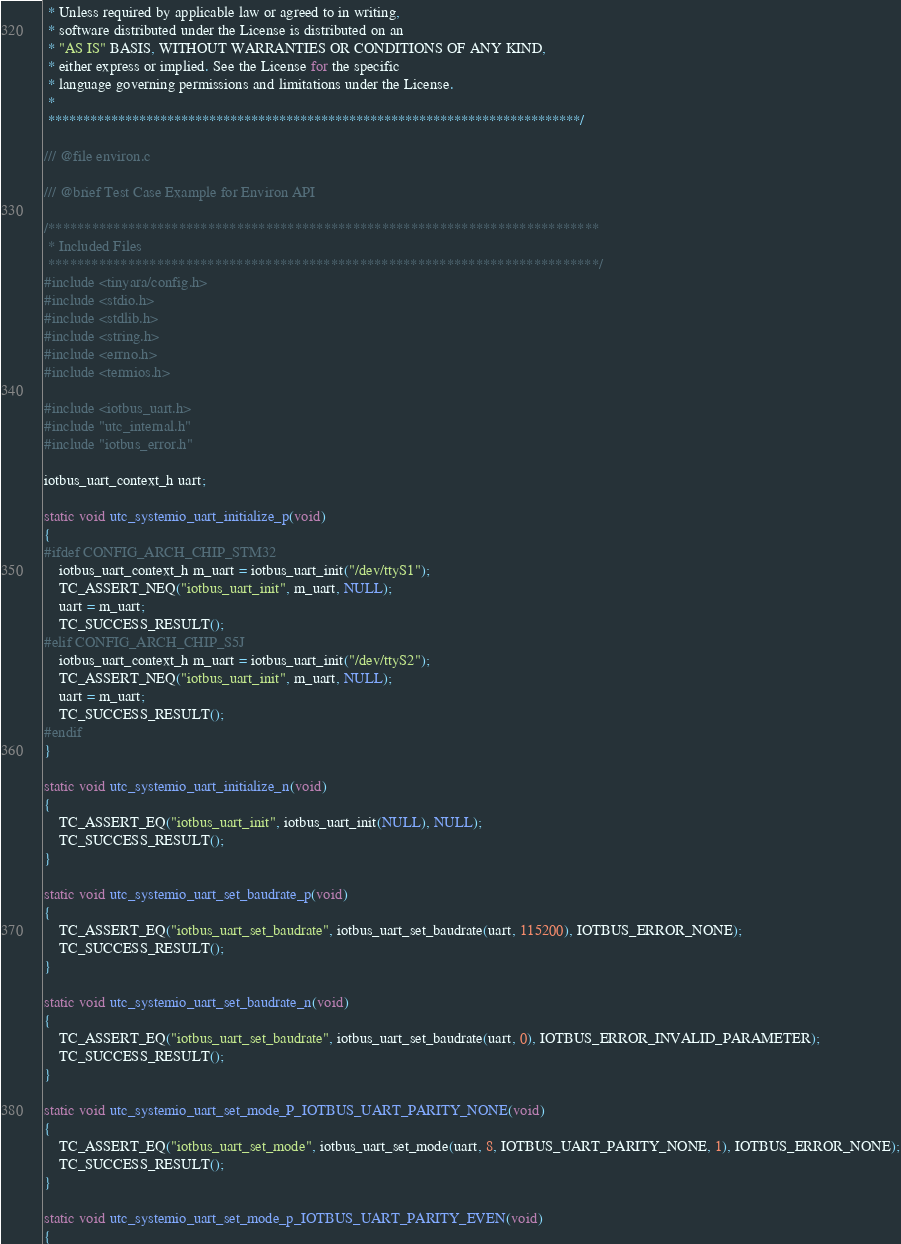Convert code to text. <code><loc_0><loc_0><loc_500><loc_500><_C_> * Unless required by applicable law or agreed to in writing,
 * software distributed under the License is distributed on an
 * "AS IS" BASIS, WITHOUT WARRANTIES OR CONDITIONS OF ANY KIND,
 * either express or implied. See the License for the specific
 * language governing permissions and limitations under the License.
 *
 ****************************************************************************/

/// @file environ.c

/// @brief Test Case Example for Environ API

/****************************************************************************
 * Included Files
 ****************************************************************************/
#include <tinyara/config.h>
#include <stdio.h>
#include <stdlib.h>
#include <string.h>
#include <errno.h>
#include <termios.h>

#include <iotbus_uart.h>
#include "utc_internal.h"
#include "iotbus_error.h"

iotbus_uart_context_h uart;

static void utc_systemio_uart_initialize_p(void)
{
#ifdef CONFIG_ARCH_CHIP_STM32
	iotbus_uart_context_h m_uart = iotbus_uart_init("/dev/ttyS1");
	TC_ASSERT_NEQ("iotbus_uart_init", m_uart, NULL);
	uart = m_uart;
	TC_SUCCESS_RESULT();
#elif CONFIG_ARCH_CHIP_S5J
	iotbus_uart_context_h m_uart = iotbus_uart_init("/dev/ttyS2");
	TC_ASSERT_NEQ("iotbus_uart_init", m_uart, NULL);
	uart = m_uart;
	TC_SUCCESS_RESULT();
#endif
}

static void utc_systemio_uart_initialize_n(void)
{
	TC_ASSERT_EQ("iotbus_uart_init", iotbus_uart_init(NULL), NULL);
	TC_SUCCESS_RESULT();
}

static void utc_systemio_uart_set_baudrate_p(void)
{
	TC_ASSERT_EQ("iotbus_uart_set_baudrate", iotbus_uart_set_baudrate(uart, 115200), IOTBUS_ERROR_NONE);
	TC_SUCCESS_RESULT();
}

static void utc_systemio_uart_set_baudrate_n(void)
{
	TC_ASSERT_EQ("iotbus_uart_set_baudrate", iotbus_uart_set_baudrate(uart, 0), IOTBUS_ERROR_INVALID_PARAMETER);
	TC_SUCCESS_RESULT();
}

static void utc_systemio_uart_set_mode_P_IOTBUS_UART_PARITY_NONE(void)
{
	TC_ASSERT_EQ("iotbus_uart_set_mode", iotbus_uart_set_mode(uart, 8, IOTBUS_UART_PARITY_NONE, 1), IOTBUS_ERROR_NONE);
	TC_SUCCESS_RESULT();
}

static void utc_systemio_uart_set_mode_p_IOTBUS_UART_PARITY_EVEN(void)
{</code> 